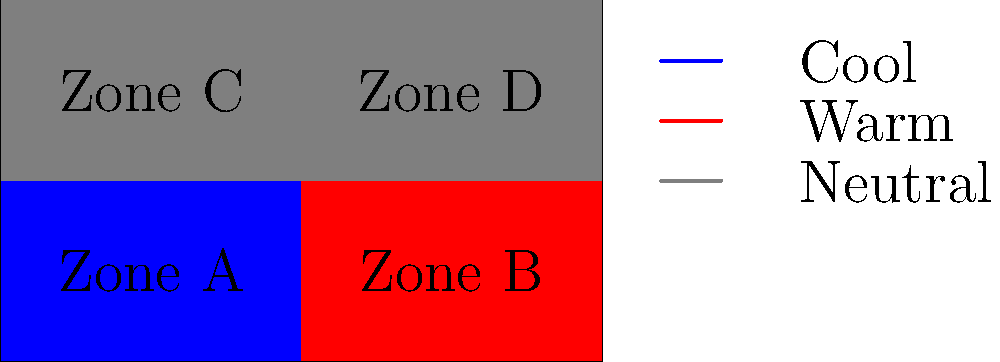Based on the color-coded floor plan showing different HVAC zoning strategies, which zone combination would likely result in the most energy-efficient operation of the smart building's HVAC system? To determine the most energy-efficient HVAC zoning strategy, we need to analyze the color-coded floor plan and consider the principles of thermal management in smart buildings:

1. Identify the zones:
   - Zone A (bottom left): Cool zone (blue)
   - Zone B (bottom right): Warm zone (red)
   - Zone C (top left): Neutral zone (gray)
   - Zone D (top right): Neutral zone (gray)

2. Analyze the thermal characteristics:
   - Cool and warm zones adjacent to each other create a thermal gradient, which can lead to energy waste.
   - Neutral zones act as buffers between different temperature zones.

3. Consider the layout:
   - Zones A and B have conflicting thermal requirements (cool vs. warm).
   - Zones C and D are neutral, providing flexibility in temperature control.

4. Evaluate energy efficiency:
   - Grouping similar thermal zones together reduces energy loss due to heat transfer between zones.
   - Separating conflicting thermal zones with neutral zones improves overall efficiency.

5. Determine the optimal combination:
   - Combining Zone A (cool) with Zone C (neutral) allows for efficient cooling without affecting the warm zone.
   - Combining Zone B (warm) with Zone D (neutral) allows for efficient heating without affecting the cool zone.

6. Consider the benefits of this combination:
   - Minimizes thermal conflicts between zones
   - Utilizes neutral zones as buffers
   - Allows for more precise temperature control in each zone
   - Reduces energy waste from heat transfer between conflicting zones

Therefore, the most energy-efficient HVAC zoning strategy would be to combine Zone A with Zone C for cooling, and Zone B with Zone D for heating.
Answer: A+C for cooling, B+D for heating 